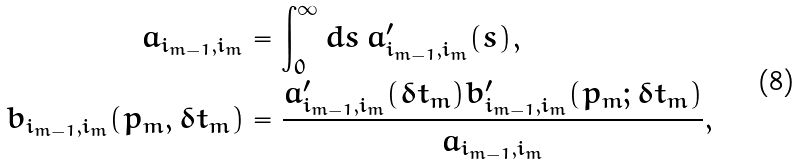Convert formula to latex. <formula><loc_0><loc_0><loc_500><loc_500>a _ { i _ { m - 1 } , i _ { m } } & = \int _ { 0 } ^ { \infty } d s \, a ^ { \prime } _ { i _ { m - 1 } , i _ { m } } ( s ) , \\ b _ { i _ { m - 1 } , i _ { m } } ( p _ { m } , \delta t _ { m } ) & = \frac { a ^ { \prime } _ { i _ { m - 1 } , i _ { m } } ( \delta t _ { m } ) b ^ { \prime } _ { i _ { m - 1 } , i _ { m } } ( p _ { m } ; \delta t _ { m } ) } { a _ { i _ { m - 1 } , i _ { m } } } ,</formula> 